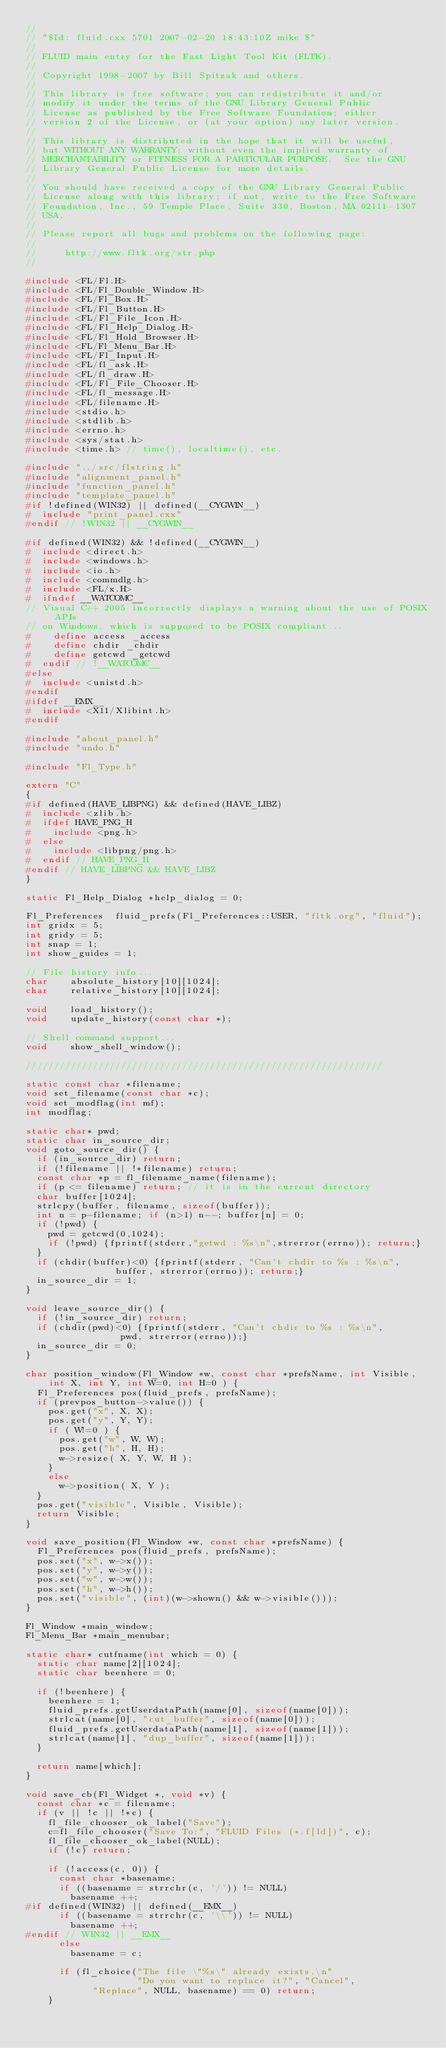<code> <loc_0><loc_0><loc_500><loc_500><_C++_>//
// "$Id: fluid.cxx 5701 2007-02-20 18:43:10Z mike $"
//
// FLUID main entry for the Fast Light Tool Kit (FLTK).
//
// Copyright 1998-2007 by Bill Spitzak and others.
//
// This library is free software; you can redistribute it and/or
// modify it under the terms of the GNU Library General Public
// License as published by the Free Software Foundation; either
// version 2 of the License, or (at your option) any later version.
//
// This library is distributed in the hope that it will be useful,
// but WITHOUT ANY WARRANTY; without even the implied warranty of
// MERCHANTABILITY or FITNESS FOR A PARTICULAR PURPOSE.  See the GNU
// Library General Public License for more details.
//
// You should have received a copy of the GNU Library General Public
// License along with this library; if not, write to the Free Software
// Foundation, Inc., 59 Temple Place, Suite 330, Boston, MA 02111-1307
// USA.
//
// Please report all bugs and problems on the following page:
//
//     http://www.fltk.org/str.php
//

#include <FL/Fl.H>
#include <FL/Fl_Double_Window.H>
#include <FL/Fl_Box.H>
#include <FL/Fl_Button.H>
#include <FL/Fl_File_Icon.H>
#include <FL/Fl_Help_Dialog.H>
#include <FL/Fl_Hold_Browser.H>
#include <FL/Fl_Menu_Bar.H>
#include <FL/Fl_Input.H>
#include <FL/fl_ask.H>
#include <FL/fl_draw.H>
#include <FL/Fl_File_Chooser.H>
#include <FL/fl_message.H>
#include <FL/filename.H>
#include <stdio.h>
#include <stdlib.h>
#include <errno.h>
#include <sys/stat.h>
#include <time.h> // time(), localtime(), etc.

#include "../src/flstring.h"
#include "alignment_panel.h"
#include "function_panel.h"
#include "template_panel.h"
#if !defined(WIN32) || defined(__CYGWIN__)
#  include "print_panel.cxx"
#endif // !WIN32 || __CYGWIN__

#if defined(WIN32) && !defined(__CYGWIN__)
#  include <direct.h>
#  include <windows.h>
#  include <io.h>
#  include <commdlg.h>
#  include <FL/x.H>
#  ifndef __WATCOMC__
// Visual C++ 2005 incorrectly displays a warning about the use of POSIX APIs
// on Windows, which is supposed to be POSIX compliant...
#    define access _access
#    define chdir _chdir
#    define getcwd _getcwd
#  endif // !__WATCOMC__
#else
#  include <unistd.h>
#endif
#ifdef __EMX__
#  include <X11/Xlibint.h>
#endif

#include "about_panel.h"
#include "undo.h"

#include "Fl_Type.h"

extern "C"
{
#if defined(HAVE_LIBPNG) && defined(HAVE_LIBZ)
#  include <zlib.h>
#  ifdef HAVE_PNG_H
#    include <png.h>
#  else
#    include <libpng/png.h>
#  endif // HAVE_PNG_H
#endif // HAVE_LIBPNG && HAVE_LIBZ
}

static Fl_Help_Dialog *help_dialog = 0;

Fl_Preferences	fluid_prefs(Fl_Preferences::USER, "fltk.org", "fluid");
int gridx = 5;
int gridy = 5;
int snap = 1;
int show_guides = 1;

// File history info...
char	absolute_history[10][1024];
char	relative_history[10][1024];

void	load_history();
void	update_history(const char *);

// Shell command support...
void	show_shell_window();

////////////////////////////////////////////////////////////////

static const char *filename;
void set_filename(const char *c);
void set_modflag(int mf);
int modflag;

static char* pwd;
static char in_source_dir;
void goto_source_dir() {
  if (in_source_dir) return;
  if (!filename || !*filename) return;
  const char *p = fl_filename_name(filename);
  if (p <= filename) return; // it is in the current directory
  char buffer[1024];
  strlcpy(buffer, filename, sizeof(buffer));
  int n = p-filename; if (n>1) n--; buffer[n] = 0;
  if (!pwd) {
    pwd = getcwd(0,1024);
    if (!pwd) {fprintf(stderr,"getwd : %s\n",strerror(errno)); return;}
  }
  if (chdir(buffer)<0) {fprintf(stderr, "Can't chdir to %s : %s\n",
				buffer, strerror(errno)); return;}
  in_source_dir = 1;
}

void leave_source_dir() {
  if (!in_source_dir) return;
  if (chdir(pwd)<0) {fprintf(stderr, "Can't chdir to %s : %s\n",
			     pwd, strerror(errno));}
  in_source_dir = 0;
}
  
char position_window(Fl_Window *w, const char *prefsName, int Visible, int X, int Y, int W=0, int H=0 ) {
  Fl_Preferences pos(fluid_prefs, prefsName);
  if (prevpos_button->value()) {
    pos.get("x", X, X);
    pos.get("y", Y, Y);
    if ( W!=0 ) {
      pos.get("w", W, W);
      pos.get("h", H, H);
      w->resize( X, Y, W, H );
    }
    else
      w->position( X, Y );
  }
  pos.get("visible", Visible, Visible);
  return Visible;
}

void save_position(Fl_Window *w, const char *prefsName) {
  Fl_Preferences pos(fluid_prefs, prefsName);
  pos.set("x", w->x());
  pos.set("y", w->y());
  pos.set("w", w->w());
  pos.set("h", w->h());
  pos.set("visible", (int)(w->shown() && w->visible()));
}

Fl_Window *main_window;
Fl_Menu_Bar *main_menubar;

static char* cutfname(int which = 0) {
  static char name[2][1024];
  static char beenhere = 0;

  if (!beenhere) {
    beenhere = 1;
    fluid_prefs.getUserdataPath(name[0], sizeof(name[0]));
    strlcat(name[0], "cut_buffer", sizeof(name[0]));
    fluid_prefs.getUserdataPath(name[1], sizeof(name[1]));
    strlcat(name[1], "dup_buffer", sizeof(name[1]));
  }

  return name[which];
}

void save_cb(Fl_Widget *, void *v) {
  const char *c = filename;
  if (v || !c || !*c) {
    fl_file_chooser_ok_label("Save");
    c=fl_file_chooser("Save To:", "FLUID Files (*.f[ld])", c);
    fl_file_chooser_ok_label(NULL);
    if (!c) return;

    if (!access(c, 0)) {
      const char *basename;
      if ((basename = strrchr(c, '/')) != NULL)
        basename ++;
#if defined(WIN32) || defined(__EMX__)
      if ((basename = strrchr(c, '\\')) != NULL)
        basename ++;
#endif // WIN32 || __EMX__
      else
        basename = c;

      if (fl_choice("The file \"%s\" already exists.\n"
                    "Do you want to replace it?", "Cancel",
		    "Replace", NULL, basename) == 0) return;
    }
</code> 